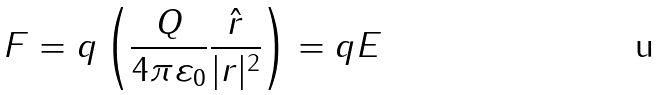Convert formula to latex. <formula><loc_0><loc_0><loc_500><loc_500>F = q \left ( { \frac { Q } { 4 \pi \varepsilon _ { 0 } } } { \frac { \hat { r } } { | r | ^ { 2 } } } \right ) = q E</formula> 